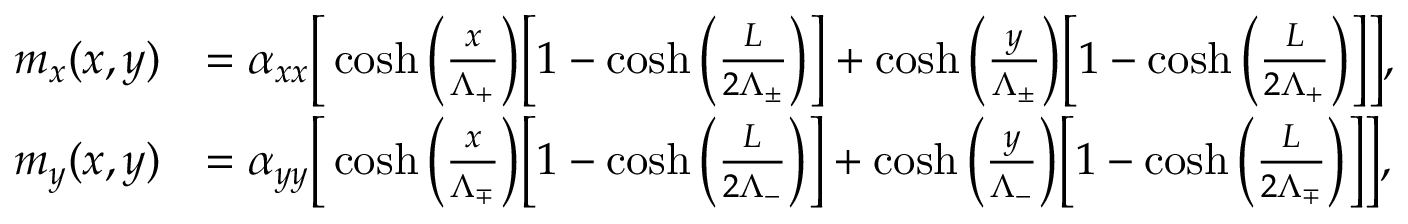<formula> <loc_0><loc_0><loc_500><loc_500>\begin{array} { r l } { m _ { x } ( x , y ) } & { = \alpha _ { x x } \left [ \cosh \left ( \frac { x } { \Lambda _ { + } } \right ) \left [ 1 - \cosh \left ( \frac { L } { 2 \Lambda _ { \pm } } \right ) \right ] + \cosh \left ( \frac { y } { \Lambda _ { \pm } } \right ) \left [ 1 - \cosh \left ( \frac { L } { 2 \Lambda _ { + } } \right ) \right ] \right ] , } \\ { m _ { y } ( x , y ) } & { = \alpha _ { y y } \left [ \cosh \left ( \frac { x } { \Lambda _ { \mp } } \right ) \left [ 1 - \cosh \left ( \frac { L } { 2 \Lambda _ { - } } \right ) \right ] + \cosh \left ( \frac { y } { \Lambda _ { - } } \right ) \left [ 1 - \cosh \left ( \frac { L } { 2 \Lambda _ { \mp } } \right ) \right ] \right ] , } \end{array}</formula> 